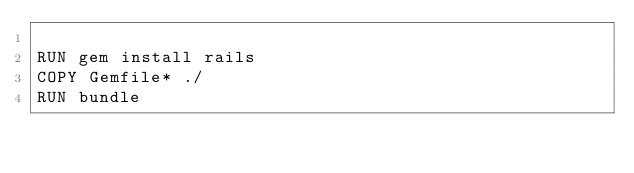Convert code to text. <code><loc_0><loc_0><loc_500><loc_500><_Dockerfile_>
RUN gem install rails
COPY Gemfile* ./
RUN bundle
</code> 